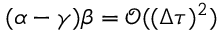Convert formula to latex. <formula><loc_0><loc_0><loc_500><loc_500>( \alpha - \gamma ) \beta = \ m a t h s c r { O } ( ( \Delta \tau ) ^ { 2 } )</formula> 